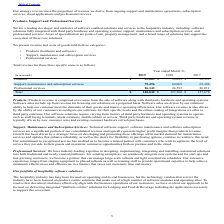According to Agilysys's financial document, What is product revenue comprised of? Products revenue is comprised of revenue from the sale of software along with third party hardware and operating systems. The document states: "Products: Products revenue is comprised of revenue from the sale of software along with third party hardware and operating systems. Software sales inc..." Also, What is the Products revenue in 2019? According to the financial document, $39,003 (in thousands). The relevant text states: "Products $ 39,003 $ 33,699 $ 38,339..." Also, What does the table show? revenue and costs of goods sold in three categories: • Products (hardware and software) • Support, maintenance and subscription services • Professional services. The document states: "We present revenue and costs of goods sold in three categories: • Products (hardware and software) • Support, maintenance and subscription services • ..." Also, can you calculate: What is the increase / (decrease) in products from 2018 to 2019? Based on the calculation: 39,003 - 33,699, the result is 5304 (in thousands). This is based on the information: "Products $ 39,003 $ 33,699 $ 38,339 Products $ 39,003 $ 33,699 $ 38,339..." The key data points involved are: 33,699, 39,003. Also, can you calculate: What is the average Support, maintenance and subscription services for 2018-2019? To answer this question, I need to perform calculations using the financial data. The calculation is: (75,496 + 69,068) / 2, which equals 72282 (in thousands). This is based on the information: "ort, maintenance and subscription services 75,496 69,068 63,308 Support, maintenance and subscription services 75,496 69,068 63,308..." The key data points involved are: 69,068, 75,496. Also, can you calculate: What was the average Professional services for 2018-2019? To answer this question, I need to perform calculations using the financial data. The calculation is: (26,343 + 24,593) / 2, which equals 25468 (in thousands). This is based on the information: "Professional services 26,343 24,593 26,031 Professional services 26,343 24,593 26,031..." The key data points involved are: 24,593, 26,343. 